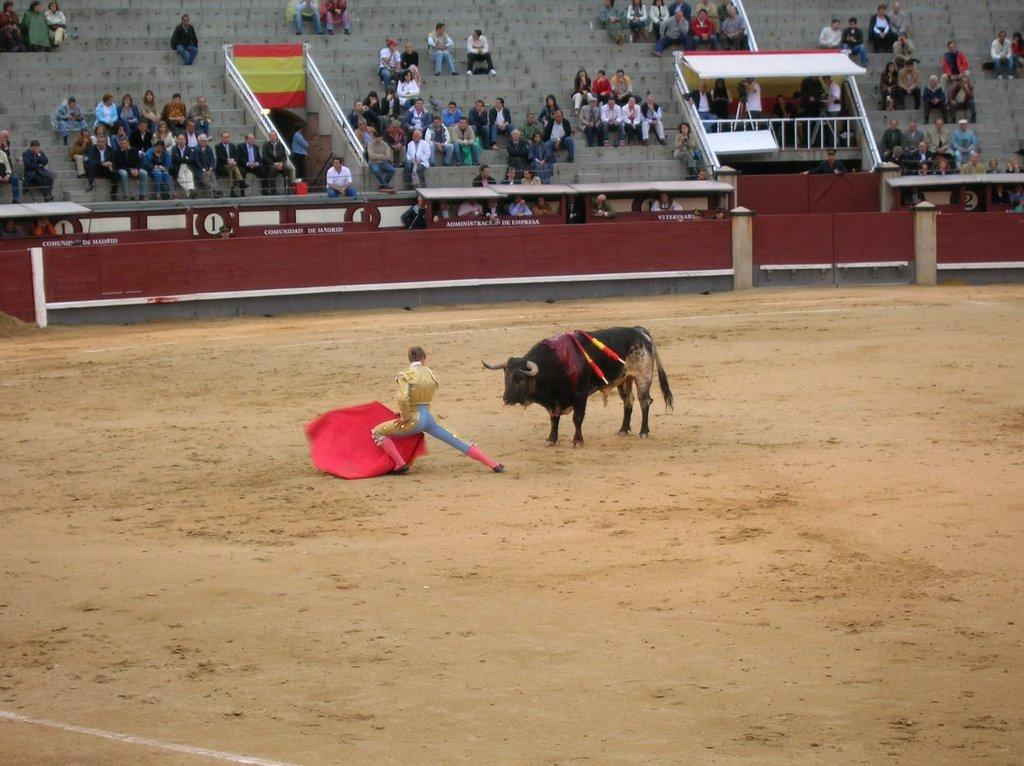What animal is the main subject of the image? There is a bull in the image. What is the person holding near the bull doing? The person is holding a red color cloth near the bull. What can be seen in the background of the image? There is a wall in the background of the image. How many people are sitting in the image? There are many people sitting in the image. What type of structure is present in the image? There are railings in the image. What type of note is the person holding near the bull? There is no note present in the image; the person is holding a red color cloth. What type of property is visible in the image? The image does not show any specific property; it features a bull, a person holding a red cloth, a wall in the background, many people sitting, and railings. 